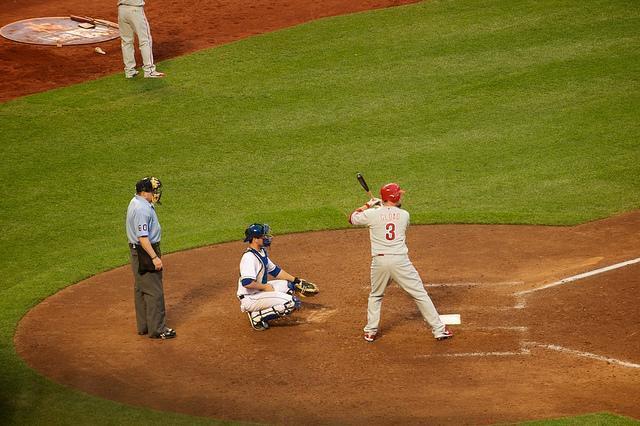Why is the batter wearing gloves?
Pick the right solution, then justify: 'Answer: answer
Rationale: rationale.'
Options: Warmth, germs, fashion, grip. Answer: grip.
Rationale: The batter needs to grip the bat. 